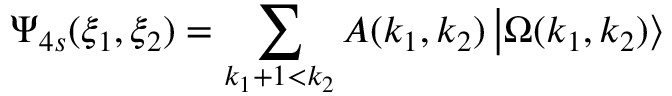Convert formula to latex. <formula><loc_0><loc_0><loc_500><loc_500>\Psi _ { 4 s } ( \xi _ { 1 } , \xi _ { 2 } ) = \sum _ { k _ { 1 } + 1 < k _ { 2 } } A ( k _ { 1 } , k _ { 2 } ) \left | \Omega ( k _ { 1 } , k _ { 2 } ) \right \rangle</formula> 